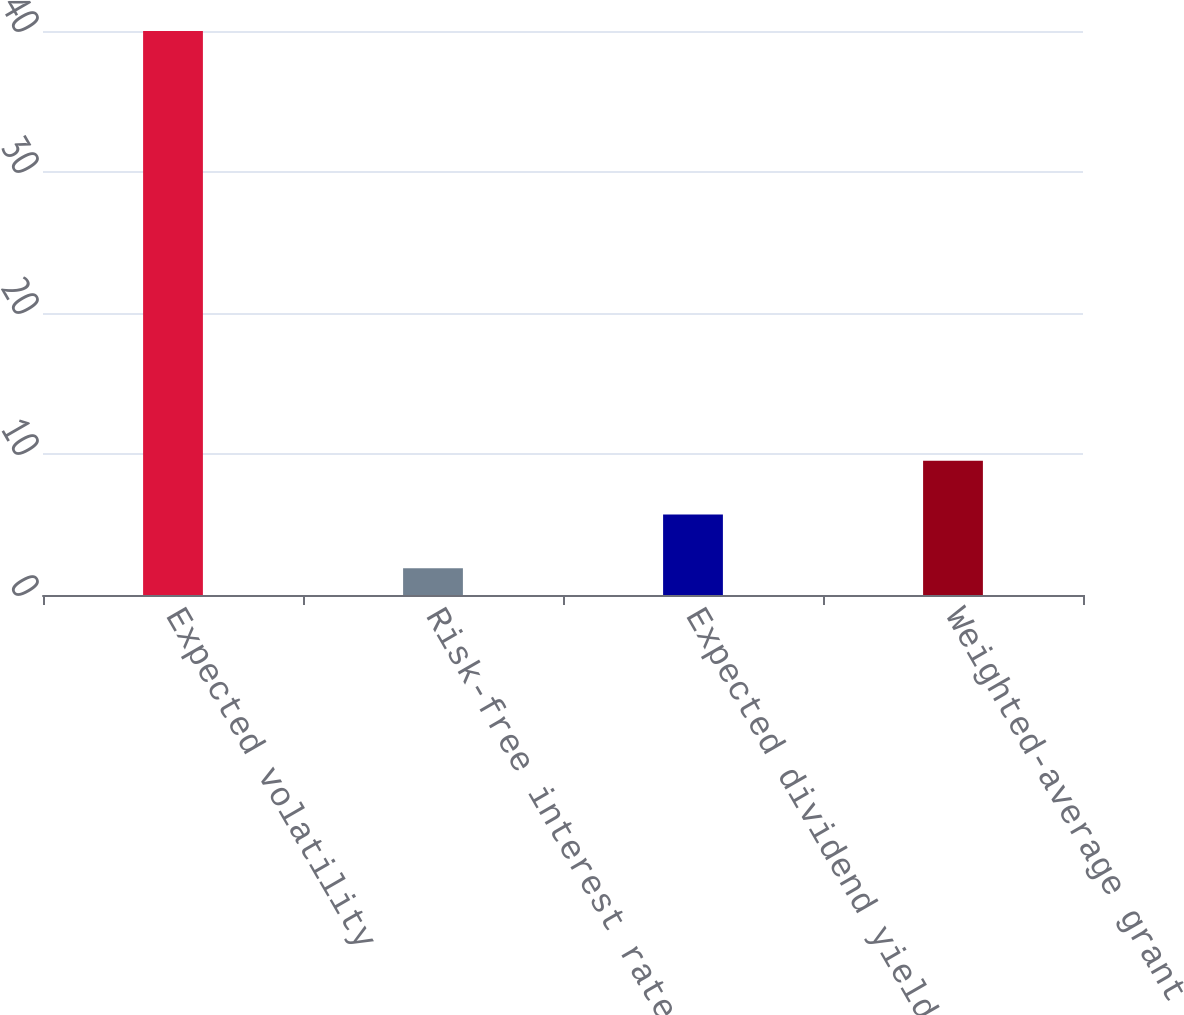Convert chart to OTSL. <chart><loc_0><loc_0><loc_500><loc_500><bar_chart><fcel>Expected volatility<fcel>Risk-free interest rate<fcel>Expected dividend yield<fcel>Weighted-average grant date<nl><fcel>40<fcel>1.9<fcel>5.71<fcel>9.52<nl></chart> 